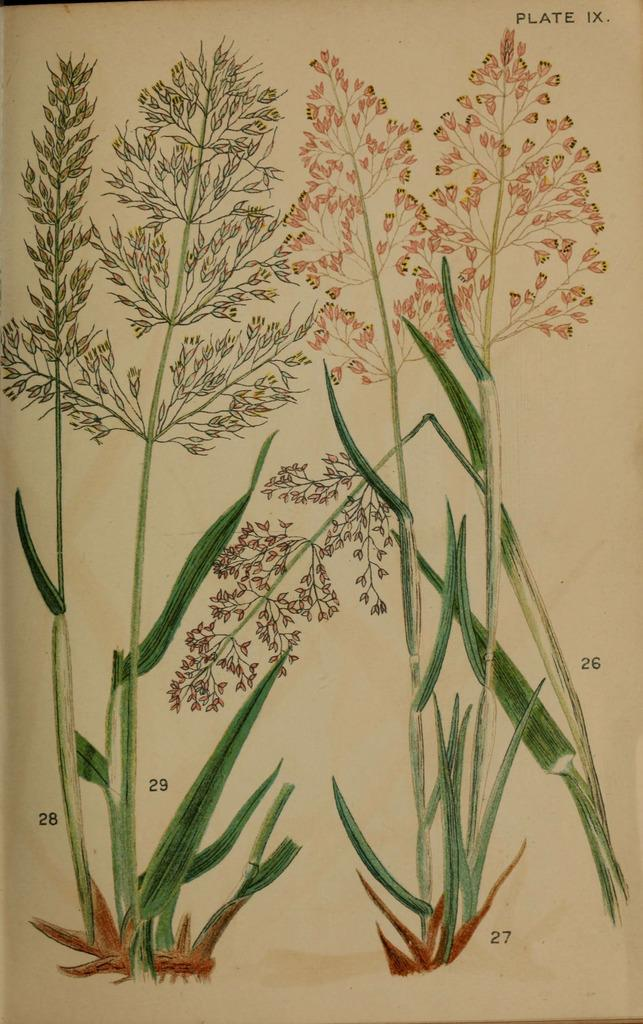What is the main subject of the image? The main subject of the image is a paper. What is on the paper? The paper contains a painting. What does the painting depict? The painting depicts plants. Can you see any mountains in the painting on the paper? There are no mountains visible in the painting on the paper; it depicts plants. What role does zinc play in the painting on the paper? Zinc is not mentioned or depicted in the painting on the paper; it is a painting of plants. 